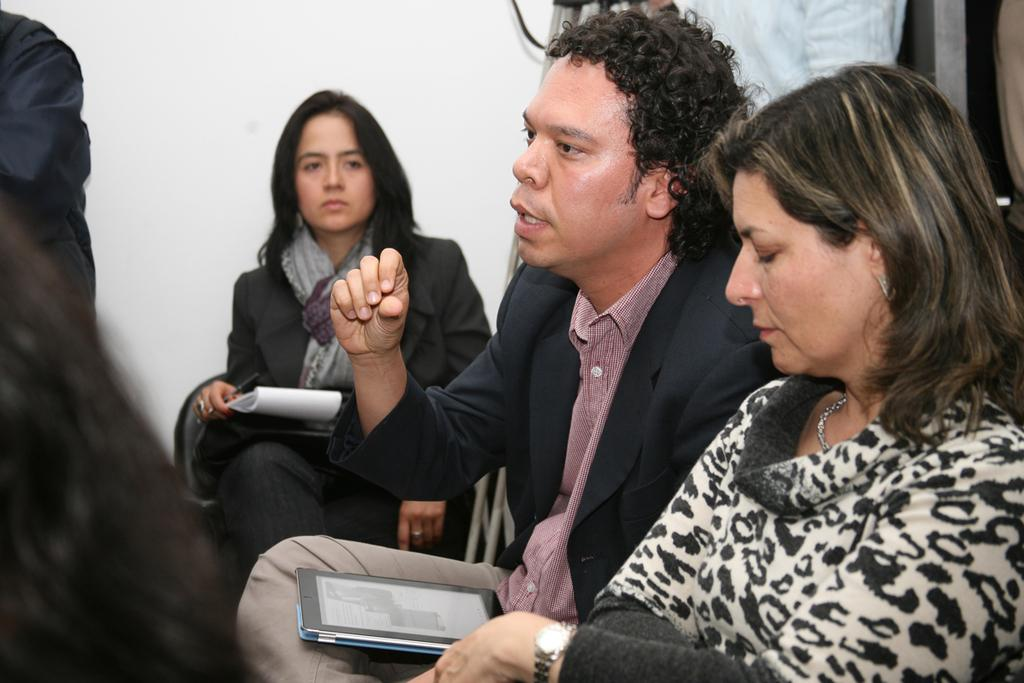How many people are present in the image? There are people in the image, but the exact number is not specified. What is the woman doing in the image? The woman is sitting and holding an object. What is the person with an object in his lap doing? The person with an object in his lap is not described in detail, so we cannot determine their actions. What type of horn can be heard in the image? There is no horn present in the image, and therefore no sound can be heard. What month is it in the image? The month is not mentioned in the image, so we cannot determine the time of year. 